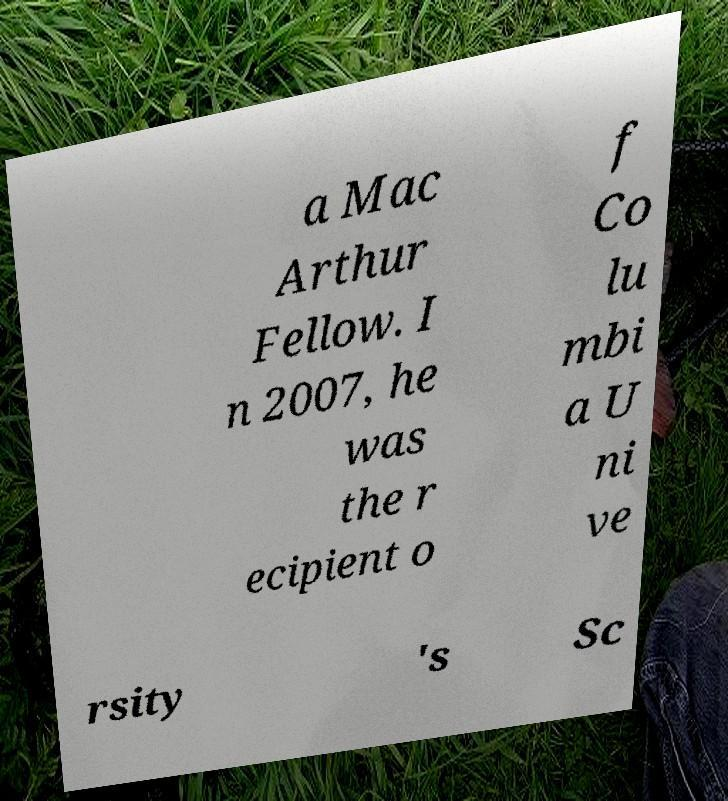Please read and relay the text visible in this image. What does it say? a Mac Arthur Fellow. I n 2007, he was the r ecipient o f Co lu mbi a U ni ve rsity 's Sc 